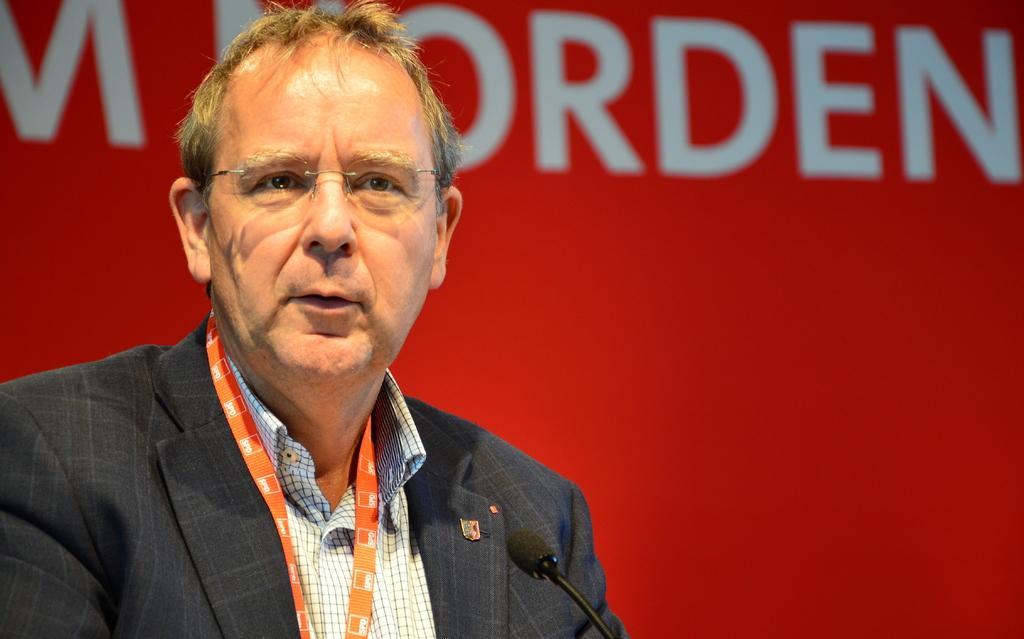How would you summarize this image in a sentence or two? In this image I can see the person and the person is wearing black blazer, white color shirt and I can also see the microphone and I can see the red and white color background. 